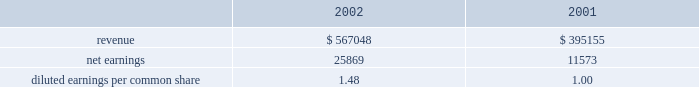Disclosure of , the issuance of certain types of guarantees .
The adoption of fasb interpretation no .
45 did not have a signif- icant impact on the net income or equity of the company .
In january 2003 , fasb interpretation no .
46 , 201cconsolidation of variable interest entities , an interpretation of arb 51 , 201d was issued .
The primary objectives of this interpretation , as amended , are to provide guidance on the identification and consolidation of variable interest entities , or vies , which are entities for which control is achieved through means other than through voting rights .
The company has completed an analysis of this interpretation and has determined that it does not have any vies .
Acquisitions family health plan , inc .
Effective january 1 , 2004 , the company commenced opera- tions in ohio through the acquisition from family health plan , inc .
Of certain medicaid-related assets for a purchase price of approximately $ 6800 .
The cost to acquire the medicaid-related assets will be allocated to the assets acquired and liabilities assumed according to estimated fair values .
Hmo blue texas effective august 1 , 2003 , the company acquired certain medicaid-related contract rights of hmo blue texas in the san antonio , texas market for $ 1045 .
The purchase price was allocated to acquired contracts , which are being amor- tized on a straight-line basis over a period of five years , the expected period of benefit .
Group practice affiliates during 2003 , the company acquired a 100% ( 100 % ) ownership interest in group practice affiliates , llc , a behavioral healthcare services company ( 63.7% ( 63.7 % ) in march 2003 and 36.3% ( 36.3 % ) in august 2003 ) .
The consolidated financial state- ments include the results of operations of gpa since march 1 , 2003 .
The company paid $ 1800 for its purchase of gpa .
The cost to acquire the ownership interest has been allocated to the assets acquired and liabilities assumed according to estimated fair values and is subject to adjustment when additional information concerning asset and liability valuations are finalized .
The preliminary allocation has resulted in goodwill of approximately $ 3895 .
The goodwill is not amortized and is not deductible for tax purposes .
Pro forma disclosures related to the acquisition have been excluded as immaterial .
Scriptassist in march 2003 , the company purchased contract and name rights of scriptassist , llc ( scriptassist ) , a medication com- pliance company .
The purchase price of $ 563 was allocated to acquired contracts , which are being amortized on a straight-line basis over a period of five years , the expected period of benefit .
The investor group who held membership interests in scriptassist included one of the company 2019s executive officers .
University health plans , inc .
On december 1 , 2002 , the company purchased 80% ( 80 % ) of the outstanding capital stock of university health plans , inc .
( uhp ) in new jersey .
In october 2003 , the company exercised its option to purchase the remaining 20% ( 20 % ) of the outstanding capital stock .
Centene paid a total purchase price of $ 13258 .
The results of operations for uhp are included in the consolidated financial statements since december 1 , 2002 .
The acquisition of uhp resulted in identified intangible assets of $ 3800 , representing purchased contract rights and provider network .
The intangibles are being amortized over a ten-year period .
Goodwill of $ 7940 is not amortized and is not deductible for tax purposes .
Changes during 2003 to the preliminary purchase price allocation primarily consisted of the purchase of the remaining 20% ( 20 % ) of the outstanding stock and the recognition of intangible assets and related deferred tax liabilities .
The following unaudited pro forma information presents the results of operations of centene and subsidiaries as if the uhp acquisition described above had occurred as of january 1 , 2001 .
These pro forma results may not necessar- ily reflect the actual results of operations that would have been achieved , nor are they necessarily indicative of future results of operations. .
Diluted earnings per common share 1.48 1.00 texas universities health plan in june 2002 , the company purchased schip contracts in three texas service areas .
The cash purchase price of $ 595 was recorded as purchased contract rights , which are being amortized on a straight-line basis over five years , the expected period of benefit .
Bankers reserve in march 2002 , the company acquired bankers reserve life insurance company of wisconsin for a cash purchase price of $ 3527 .
The company allocated the purchase price to net tangible and identifiable intangible assets based on their fair value .
Centene allocated $ 479 to identifiable intangible assets , representing the value assigned to acquired licenses , which are being amortized on a straight-line basis over a notes to consolidated financial statements ( continued ) centene corporation and subsidiaries .
What is the annual impact on pre tax net income from the goodwill in the hmo blue texas acquisition?\\n? 
Computations: (1045 / 5)
Answer: 209.0. 